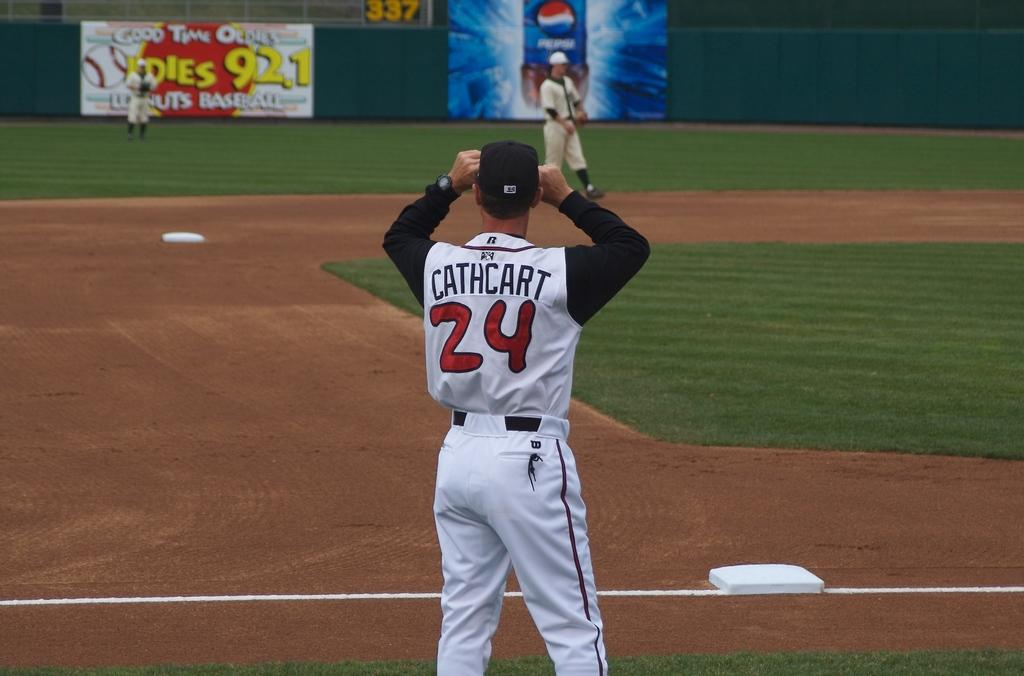<image>
Render a clear and concise summary of the photo. Baseball player in a white uniform that has Cathcart in black lettering on the back. 